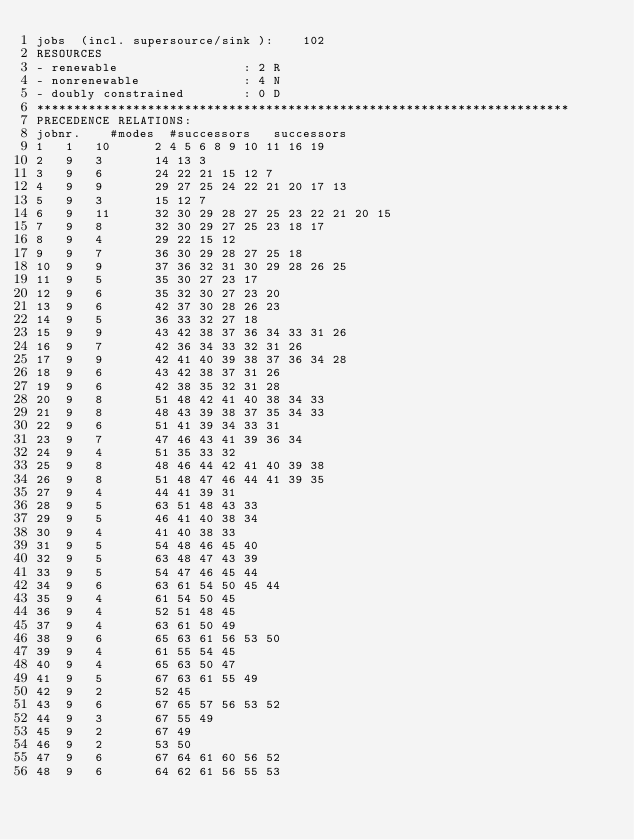Convert code to text. <code><loc_0><loc_0><loc_500><loc_500><_ObjectiveC_>jobs  (incl. supersource/sink ):	102
RESOURCES
- renewable                 : 2 R
- nonrenewable              : 4 N
- doubly constrained        : 0 D
************************************************************************
PRECEDENCE RELATIONS:
jobnr.    #modes  #successors   successors
1	1	10		2 4 5 6 8 9 10 11 16 19 
2	9	3		14 13 3 
3	9	6		24 22 21 15 12 7 
4	9	9		29 27 25 24 22 21 20 17 13 
5	9	3		15 12 7 
6	9	11		32 30 29 28 27 25 23 22 21 20 15 
7	9	8		32 30 29 27 25 23 18 17 
8	9	4		29 22 15 12 
9	9	7		36 30 29 28 27 25 18 
10	9	9		37 36 32 31 30 29 28 26 25 
11	9	5		35 30 27 23 17 
12	9	6		35 32 30 27 23 20 
13	9	6		42 37 30 28 26 23 
14	9	5		36 33 32 27 18 
15	9	9		43 42 38 37 36 34 33 31 26 
16	9	7		42 36 34 33 32 31 26 
17	9	9		42 41 40 39 38 37 36 34 28 
18	9	6		43 42 38 37 31 26 
19	9	6		42 38 35 32 31 28 
20	9	8		51 48 42 41 40 38 34 33 
21	9	8		48 43 39 38 37 35 34 33 
22	9	6		51 41 39 34 33 31 
23	9	7		47 46 43 41 39 36 34 
24	9	4		51 35 33 32 
25	9	8		48 46 44 42 41 40 39 38 
26	9	8		51 48 47 46 44 41 39 35 
27	9	4		44 41 39 31 
28	9	5		63 51 48 43 33 
29	9	5		46 41 40 38 34 
30	9	4		41 40 38 33 
31	9	5		54 48 46 45 40 
32	9	5		63 48 47 43 39 
33	9	5		54 47 46 45 44 
34	9	6		63 61 54 50 45 44 
35	9	4		61 54 50 45 
36	9	4		52 51 48 45 
37	9	4		63 61 50 49 
38	9	6		65 63 61 56 53 50 
39	9	4		61 55 54 45 
40	9	4		65 63 50 47 
41	9	5		67 63 61 55 49 
42	9	2		52 45 
43	9	6		67 65 57 56 53 52 
44	9	3		67 55 49 
45	9	2		67 49 
46	9	2		53 50 
47	9	6		67 64 61 60 56 52 
48	9	6		64 62 61 56 55 53 </code> 